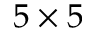Convert formula to latex. <formula><loc_0><loc_0><loc_500><loc_500>5 \times 5</formula> 